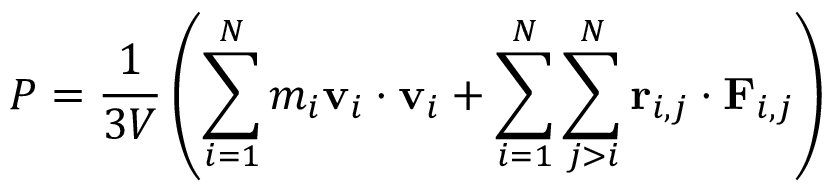<formula> <loc_0><loc_0><loc_500><loc_500>P = \frac { 1 } { 3 V } \left ( \sum _ { i = 1 } ^ { N } m _ { i } v _ { i } \cdot v _ { i } + \sum _ { i = 1 } ^ { N } \sum _ { j > i } ^ { N } r _ { i , j } \cdot F _ { i , j } \right )</formula> 